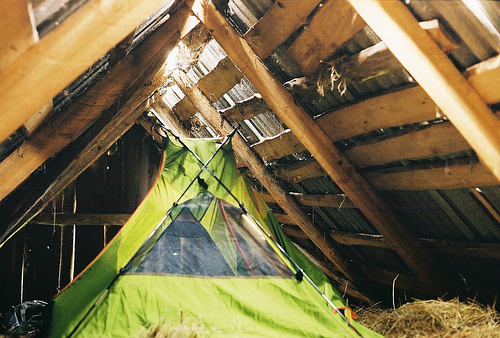<image>
Is the roof on the rafter? Yes. Looking at the image, I can see the roof is positioned on top of the rafter, with the rafter providing support. 